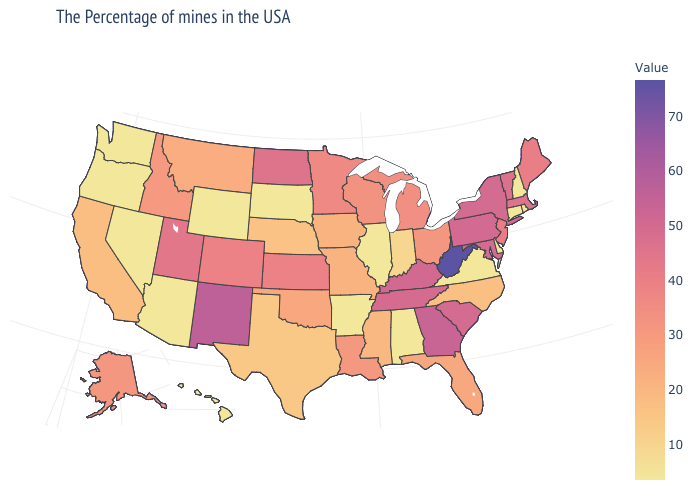Does Wisconsin have a lower value than West Virginia?
Keep it brief. Yes. Is the legend a continuous bar?
Give a very brief answer. Yes. Which states have the lowest value in the MidWest?
Answer briefly. Illinois, South Dakota. Among the states that border California , does Oregon have the lowest value?
Keep it brief. No. Among the states that border Florida , which have the highest value?
Answer briefly. Georgia. Does Oklahoma have the highest value in the USA?
Keep it brief. No. 